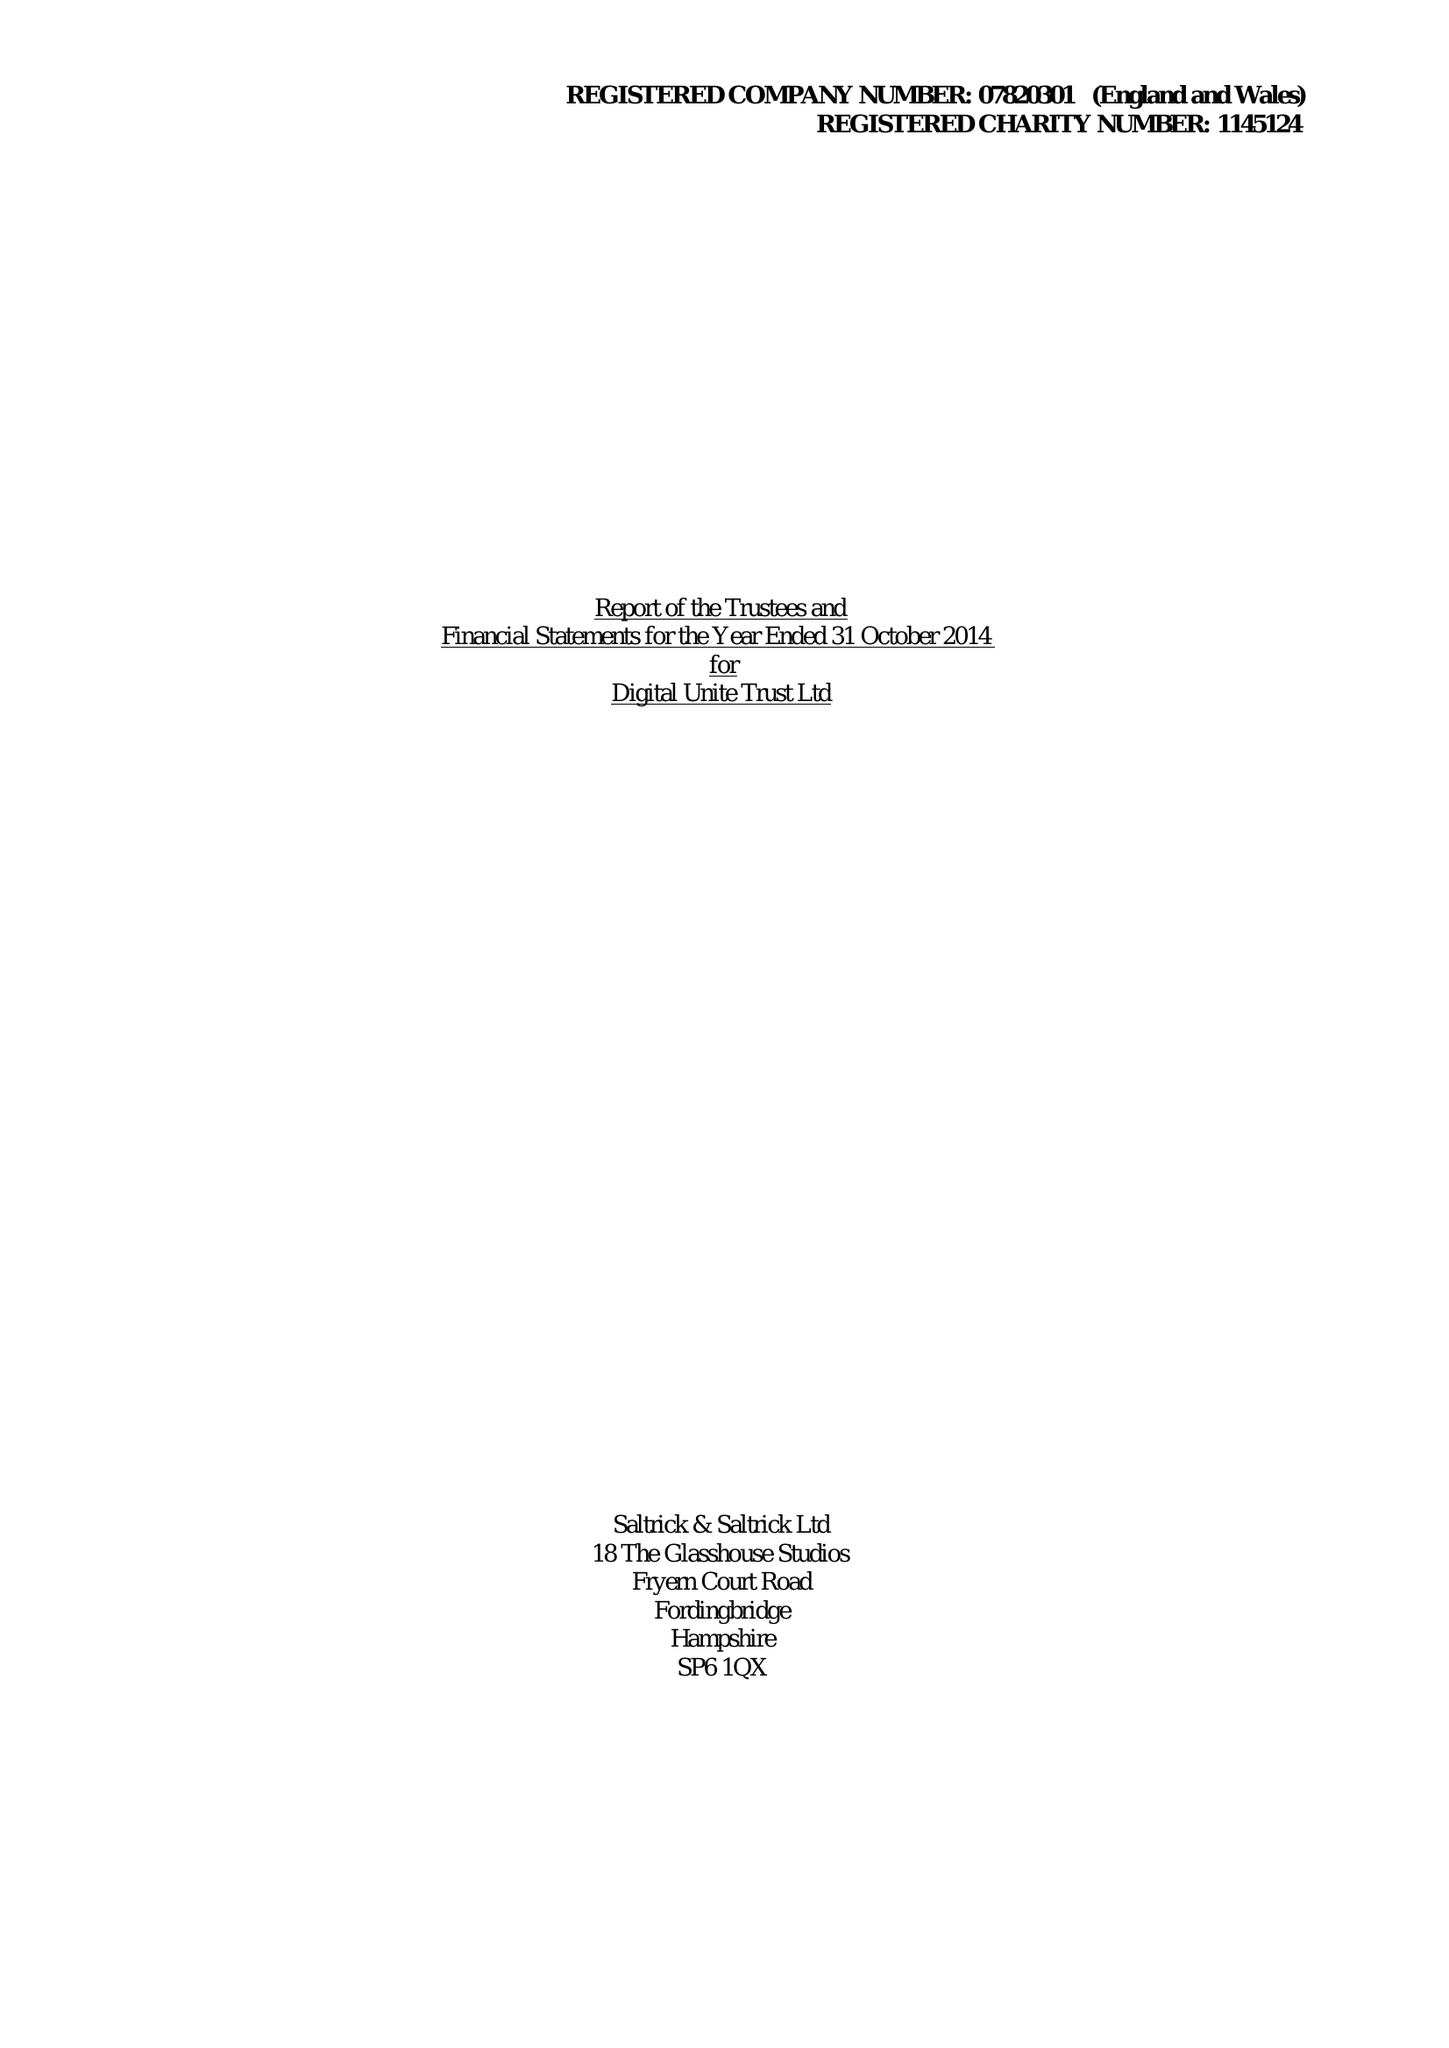What is the value for the address__post_town?
Answer the question using a single word or phrase. FAREHAM 